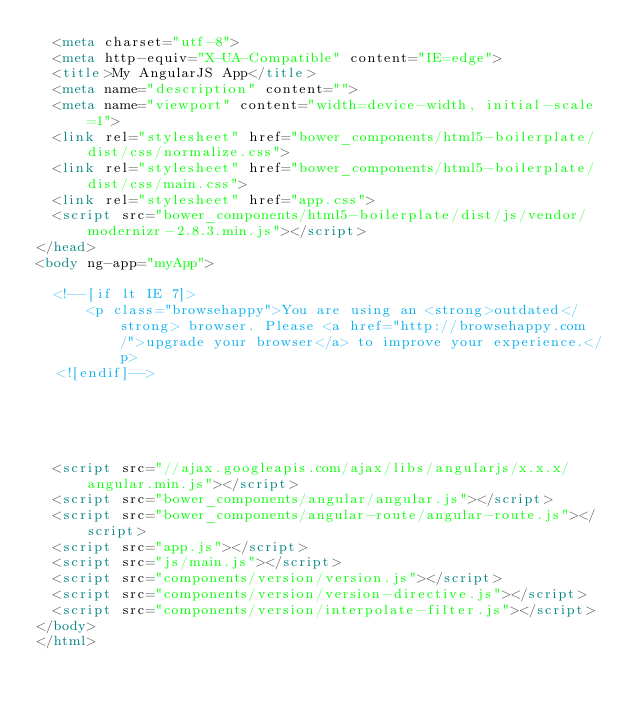Convert code to text. <code><loc_0><loc_0><loc_500><loc_500><_HTML_>  <meta charset="utf-8">
  <meta http-equiv="X-UA-Compatible" content="IE=edge">
  <title>My AngularJS App</title>
  <meta name="description" content="">
  <meta name="viewport" content="width=device-width, initial-scale=1">
  <link rel="stylesheet" href="bower_components/html5-boilerplate/dist/css/normalize.css">
  <link rel="stylesheet" href="bower_components/html5-boilerplate/dist/css/main.css">
  <link rel="stylesheet" href="app.css">
  <script src="bower_components/html5-boilerplate/dist/js/vendor/modernizr-2.8.3.min.js"></script>
</head>
<body ng-app="myApp">

  <!--[if lt IE 7]>
      <p class="browsehappy">You are using an <strong>outdated</strong> browser. Please <a href="http://browsehappy.com/">upgrade your browser</a> to improve your experience.</p>
  <![endif]-->





  <script src="//ajax.googleapis.com/ajax/libs/angularjs/x.x.x/angular.min.js"></script>
  <script src="bower_components/angular/angular.js"></script>
  <script src="bower_components/angular-route/angular-route.js"></script>
  <script src="app.js"></script>
  <script src="js/main.js"></script>
  <script src="components/version/version.js"></script>
  <script src="components/version/version-directive.js"></script>
  <script src="components/version/interpolate-filter.js"></script>
</body>
</html>
</code> 